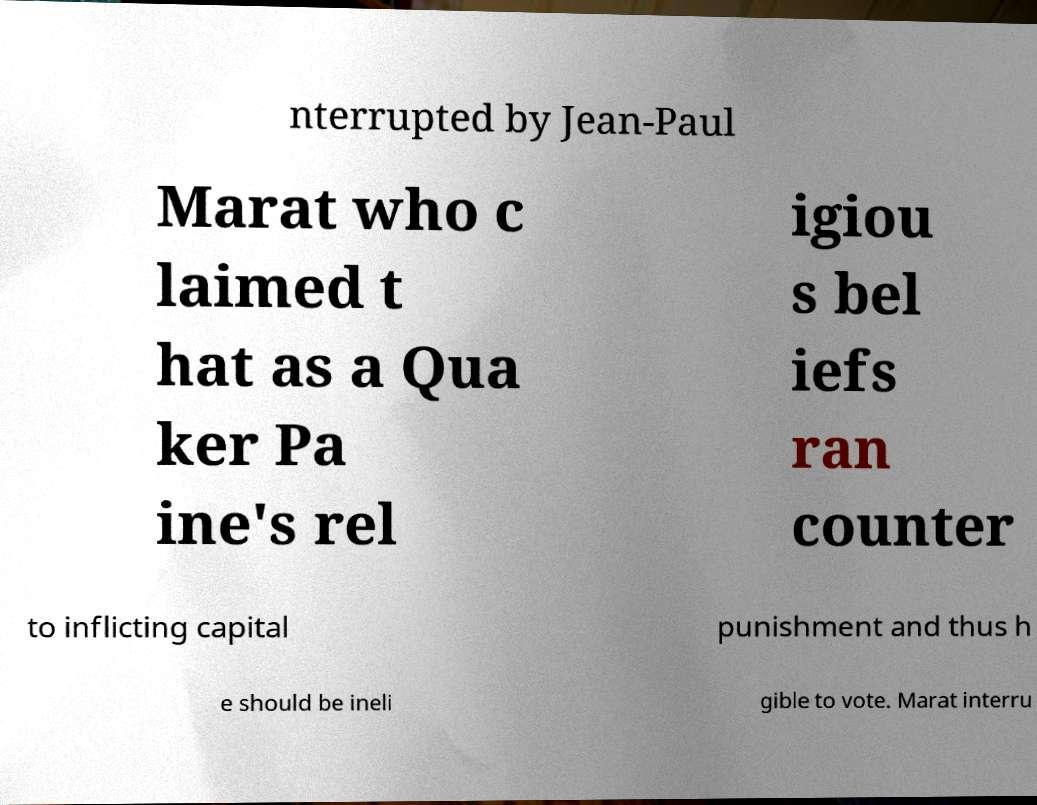Can you accurately transcribe the text from the provided image for me? nterrupted by Jean-Paul Marat who c laimed t hat as a Qua ker Pa ine's rel igiou s bel iefs ran counter to inflicting capital punishment and thus h e should be ineli gible to vote. Marat interru 